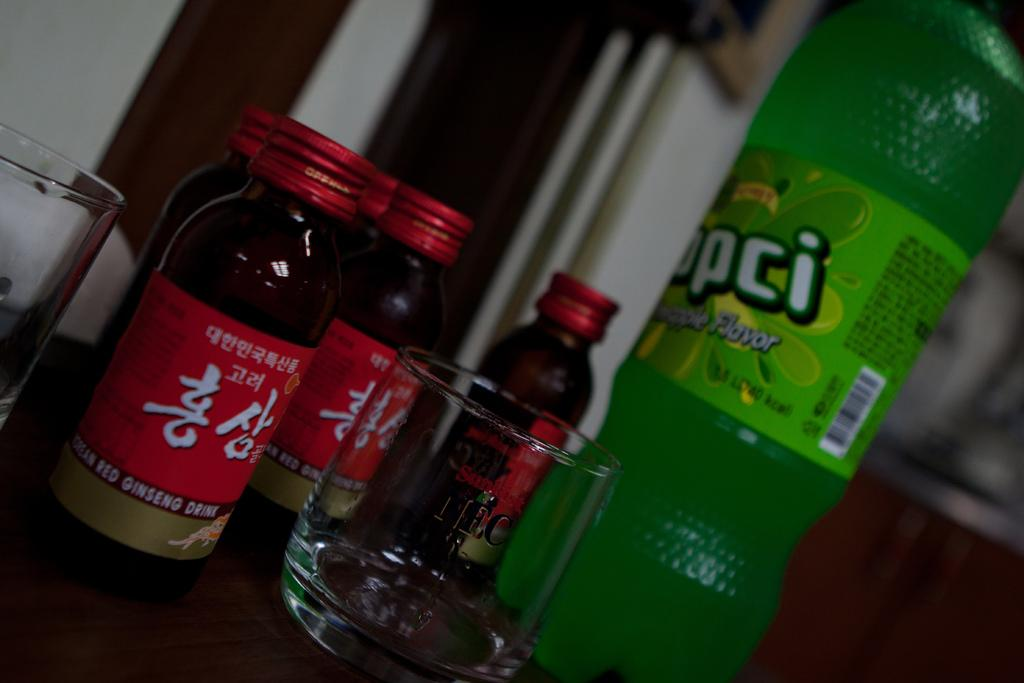<image>
Create a compact narrative representing the image presented. Green bottle that says "Apple Flavor" next to some other bottles. 